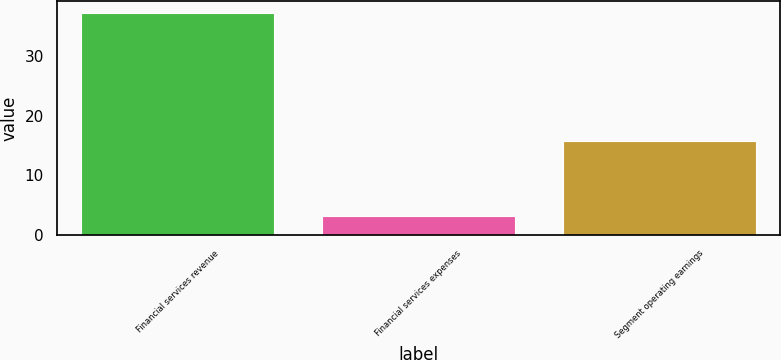<chart> <loc_0><loc_0><loc_500><loc_500><bar_chart><fcel>Financial services revenue<fcel>Financial services expenses<fcel>Segment operating earnings<nl><fcel>37.18<fcel>3.2<fcel>15.8<nl></chart> 